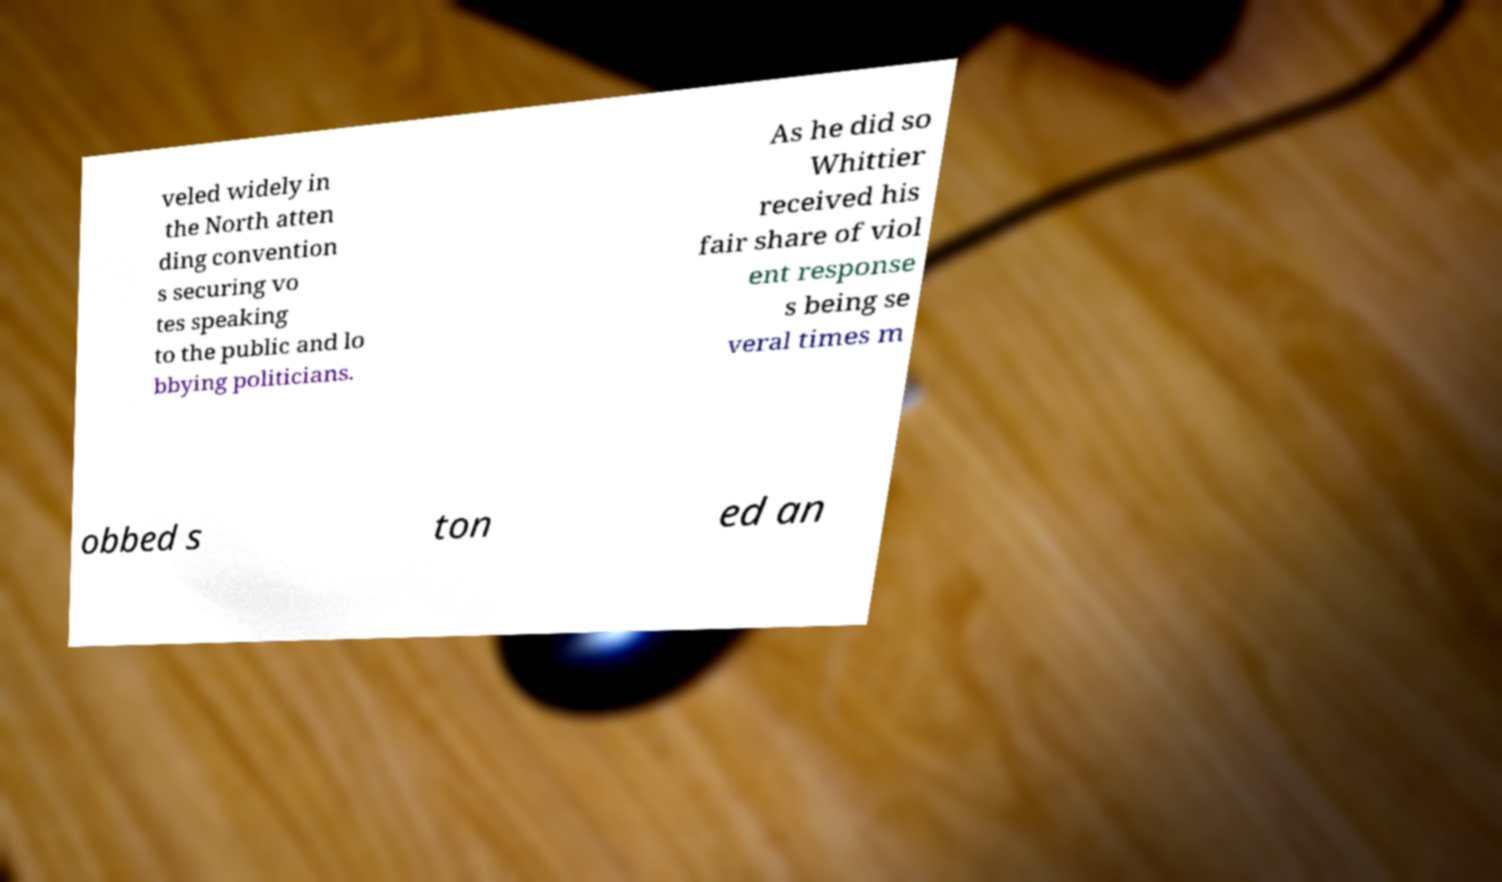Please identify and transcribe the text found in this image. veled widely in the North atten ding convention s securing vo tes speaking to the public and lo bbying politicians. As he did so Whittier received his fair share of viol ent response s being se veral times m obbed s ton ed an 